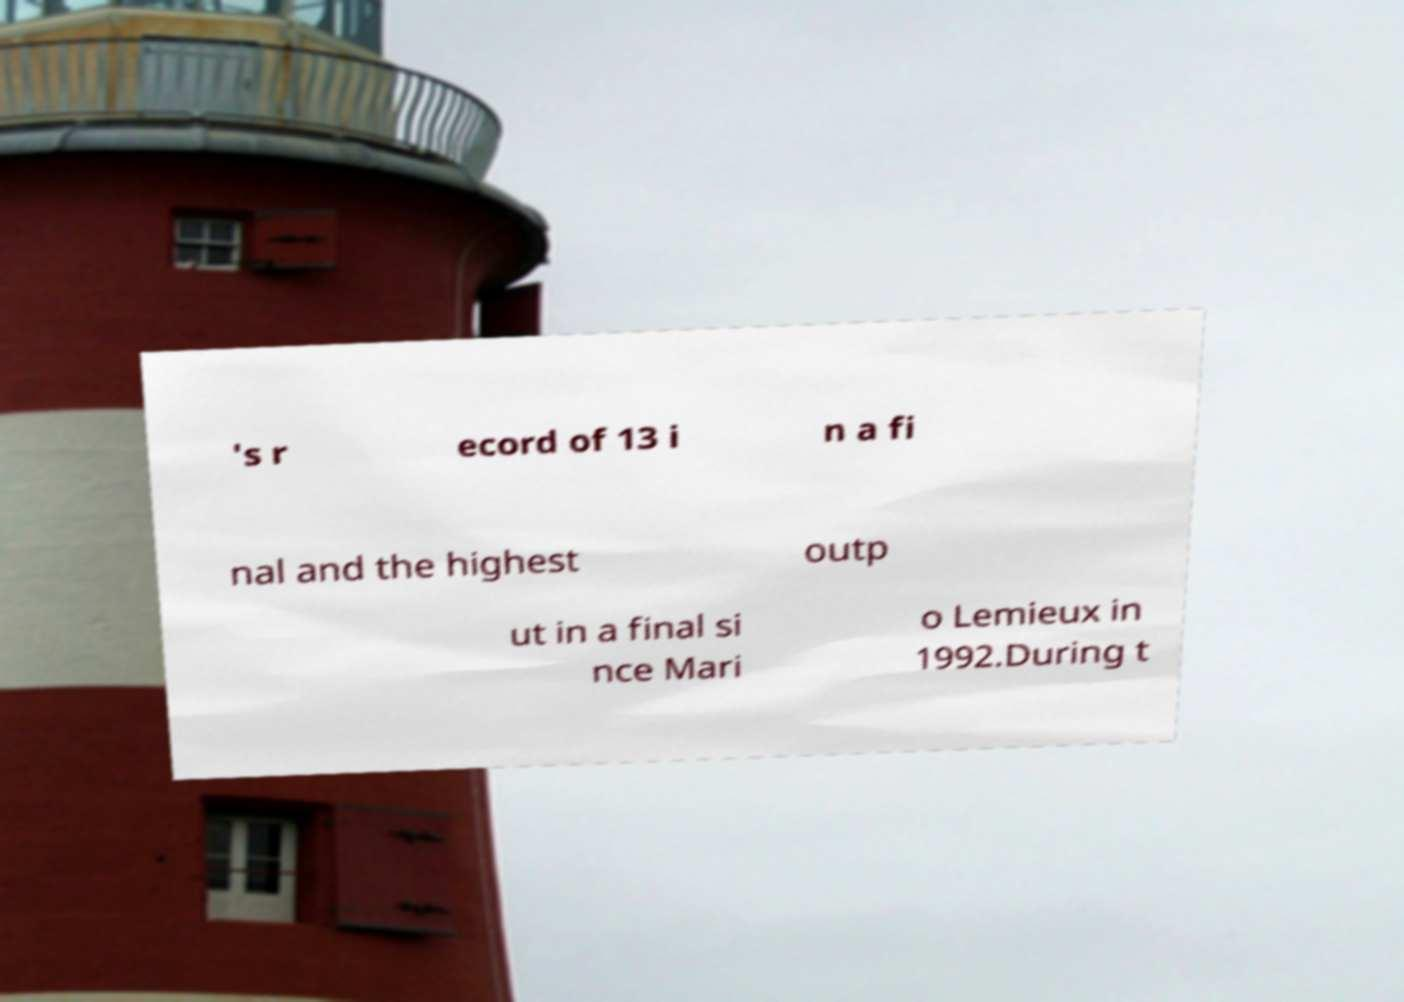Could you assist in decoding the text presented in this image and type it out clearly? 's r ecord of 13 i n a fi nal and the highest outp ut in a final si nce Mari o Lemieux in 1992.During t 